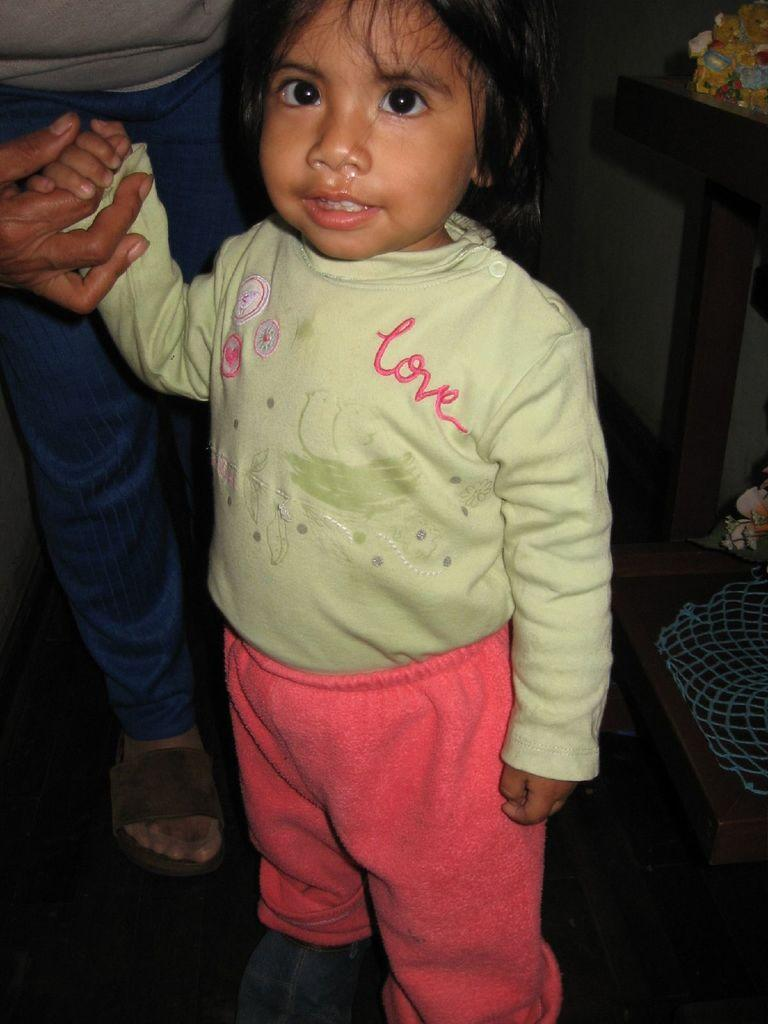Who is the main subject in the image? There is a girl standing in the front of the image. Who is with the girl in the image? There is a person holding the girl's hand. What can be seen on the right side of the image? There is a table on the right side of the image. What is on the table in the image? There is an object on the table. What type of produce is growing on the earth in the image? There is no produce or earth present in the image. What is the stem of the plant in the image? There is no plant or stem present in the image. 